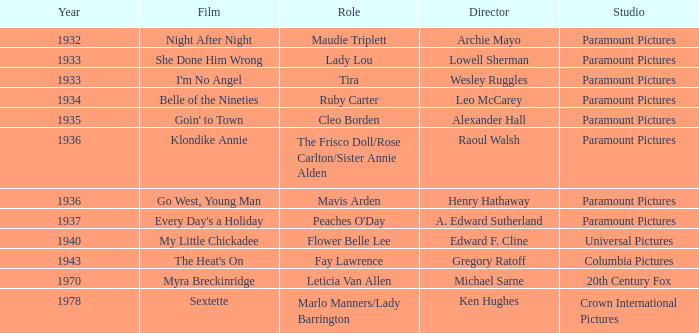When was the cinematic production klondike annie released? 1936.0. 